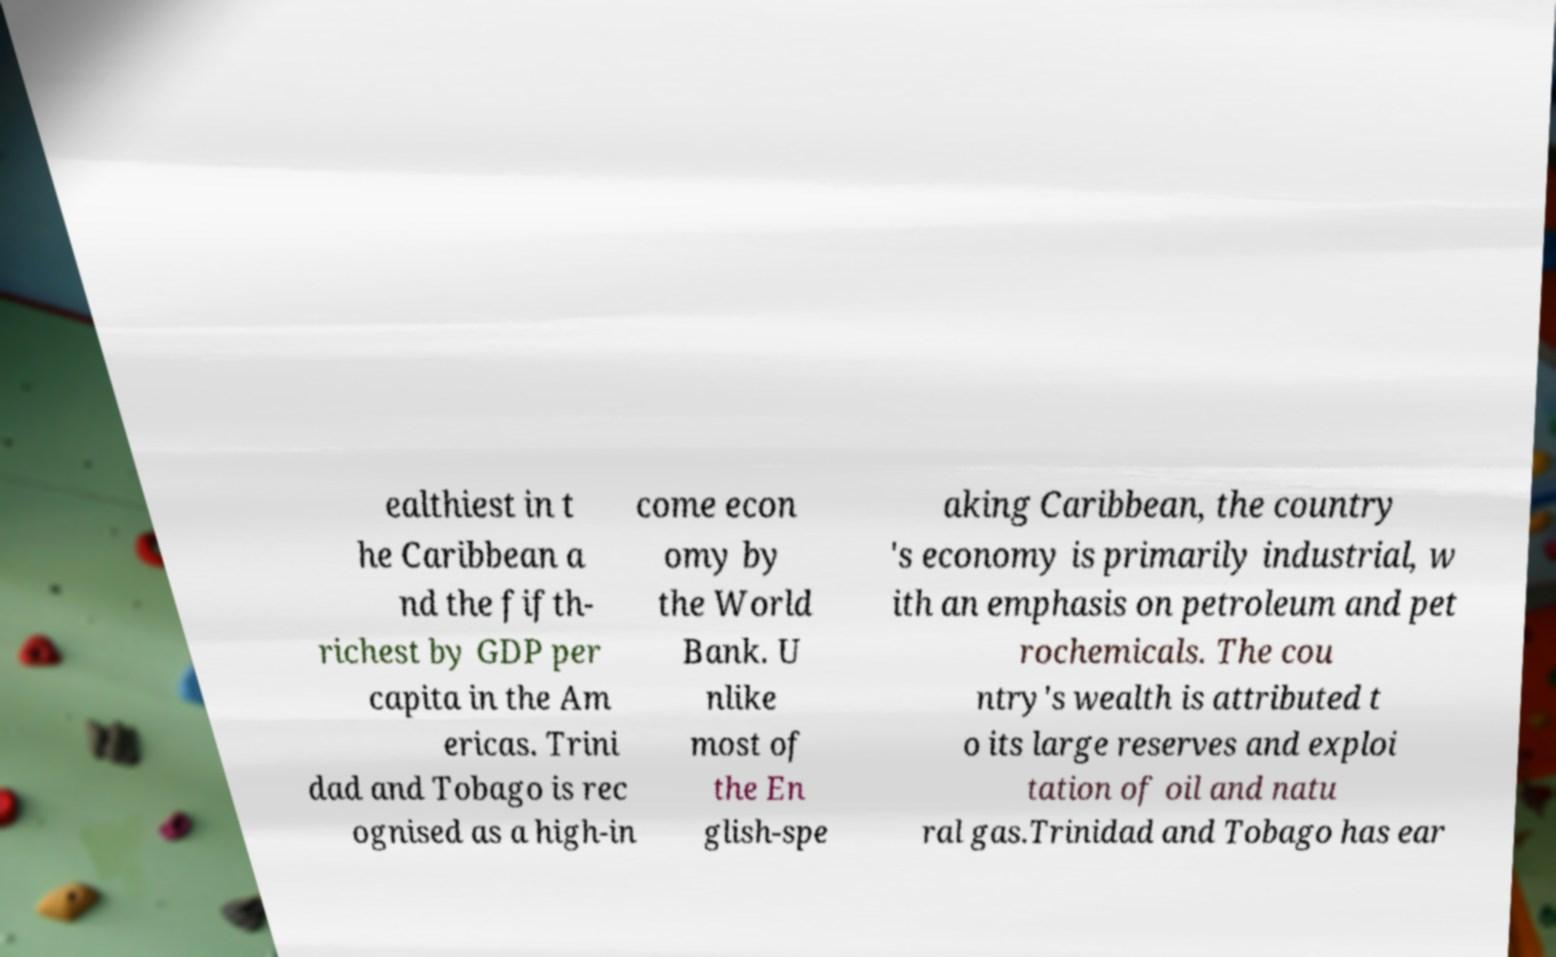Please read and relay the text visible in this image. What does it say? ealthiest in t he Caribbean a nd the fifth- richest by GDP per capita in the Am ericas. Trini dad and Tobago is rec ognised as a high-in come econ omy by the World Bank. U nlike most of the En glish-spe aking Caribbean, the country 's economy is primarily industrial, w ith an emphasis on petroleum and pet rochemicals. The cou ntry's wealth is attributed t o its large reserves and exploi tation of oil and natu ral gas.Trinidad and Tobago has ear 